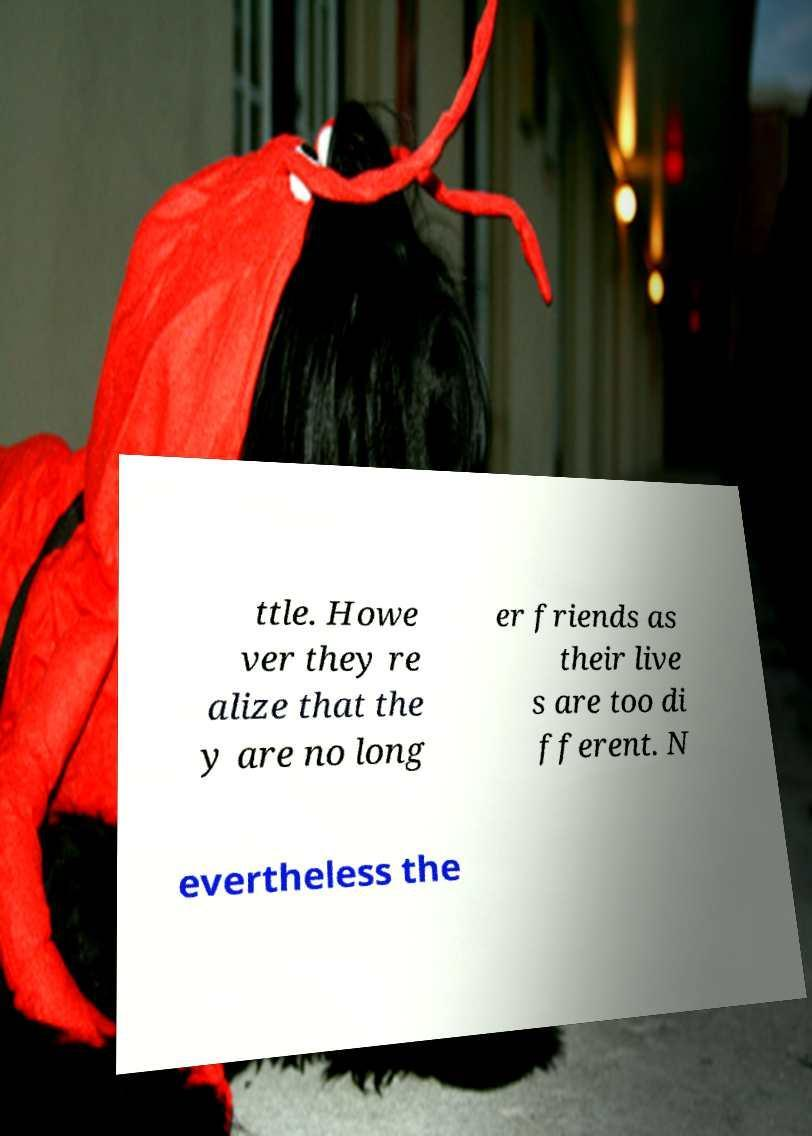For documentation purposes, I need the text within this image transcribed. Could you provide that? ttle. Howe ver they re alize that the y are no long er friends as their live s are too di fferent. N evertheless the 